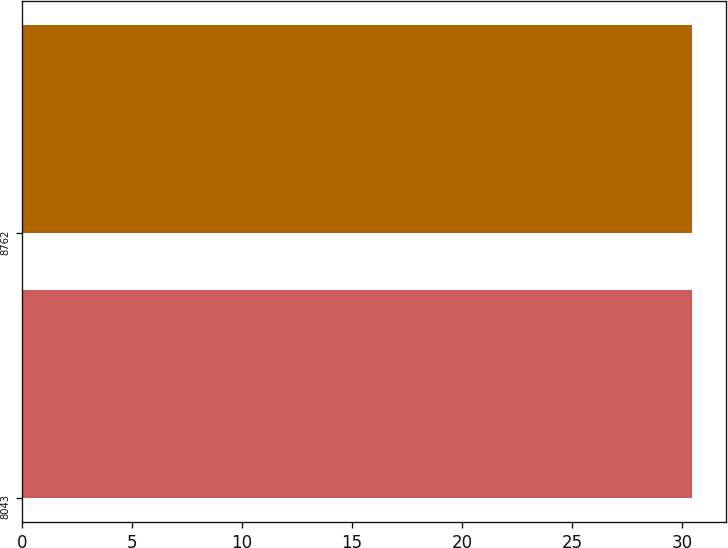Convert chart. <chart><loc_0><loc_0><loc_500><loc_500><bar_chart><fcel>8043<fcel>8762<nl><fcel>30.42<fcel>30.46<nl></chart> 